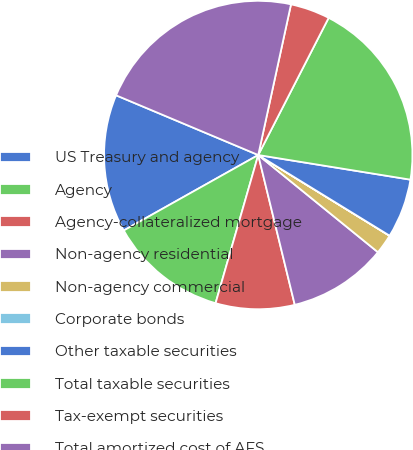Convert chart to OTSL. <chart><loc_0><loc_0><loc_500><loc_500><pie_chart><fcel>US Treasury and agency<fcel>Agency<fcel>Agency-collateralized mortgage<fcel>Non-agency residential<fcel>Non-agency commercial<fcel>Corporate bonds<fcel>Other taxable securities<fcel>Total taxable securities<fcel>Tax-exempt securities<fcel>Total amortized cost of AFS<nl><fcel>14.47%<fcel>12.4%<fcel>8.27%<fcel>10.34%<fcel>2.08%<fcel>0.01%<fcel>6.21%<fcel>20.01%<fcel>4.14%<fcel>22.08%<nl></chart> 